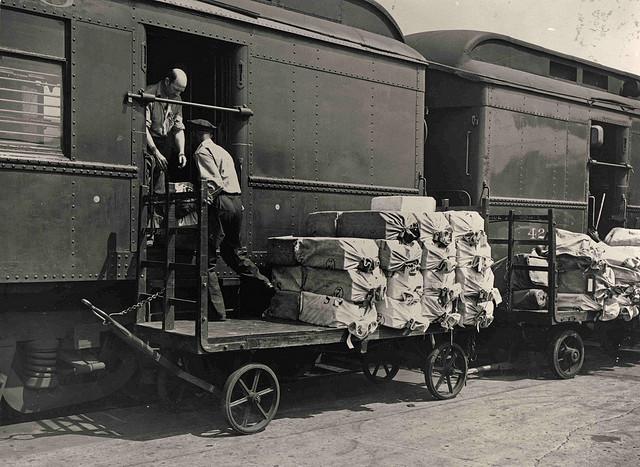What mode of transportation is the person getting into?
Answer briefly. Train. Was this photograph taken in the last 10 to 20 years?
Answer briefly. No. Is the photo in black and white or color?
Short answer required. Black and white. 